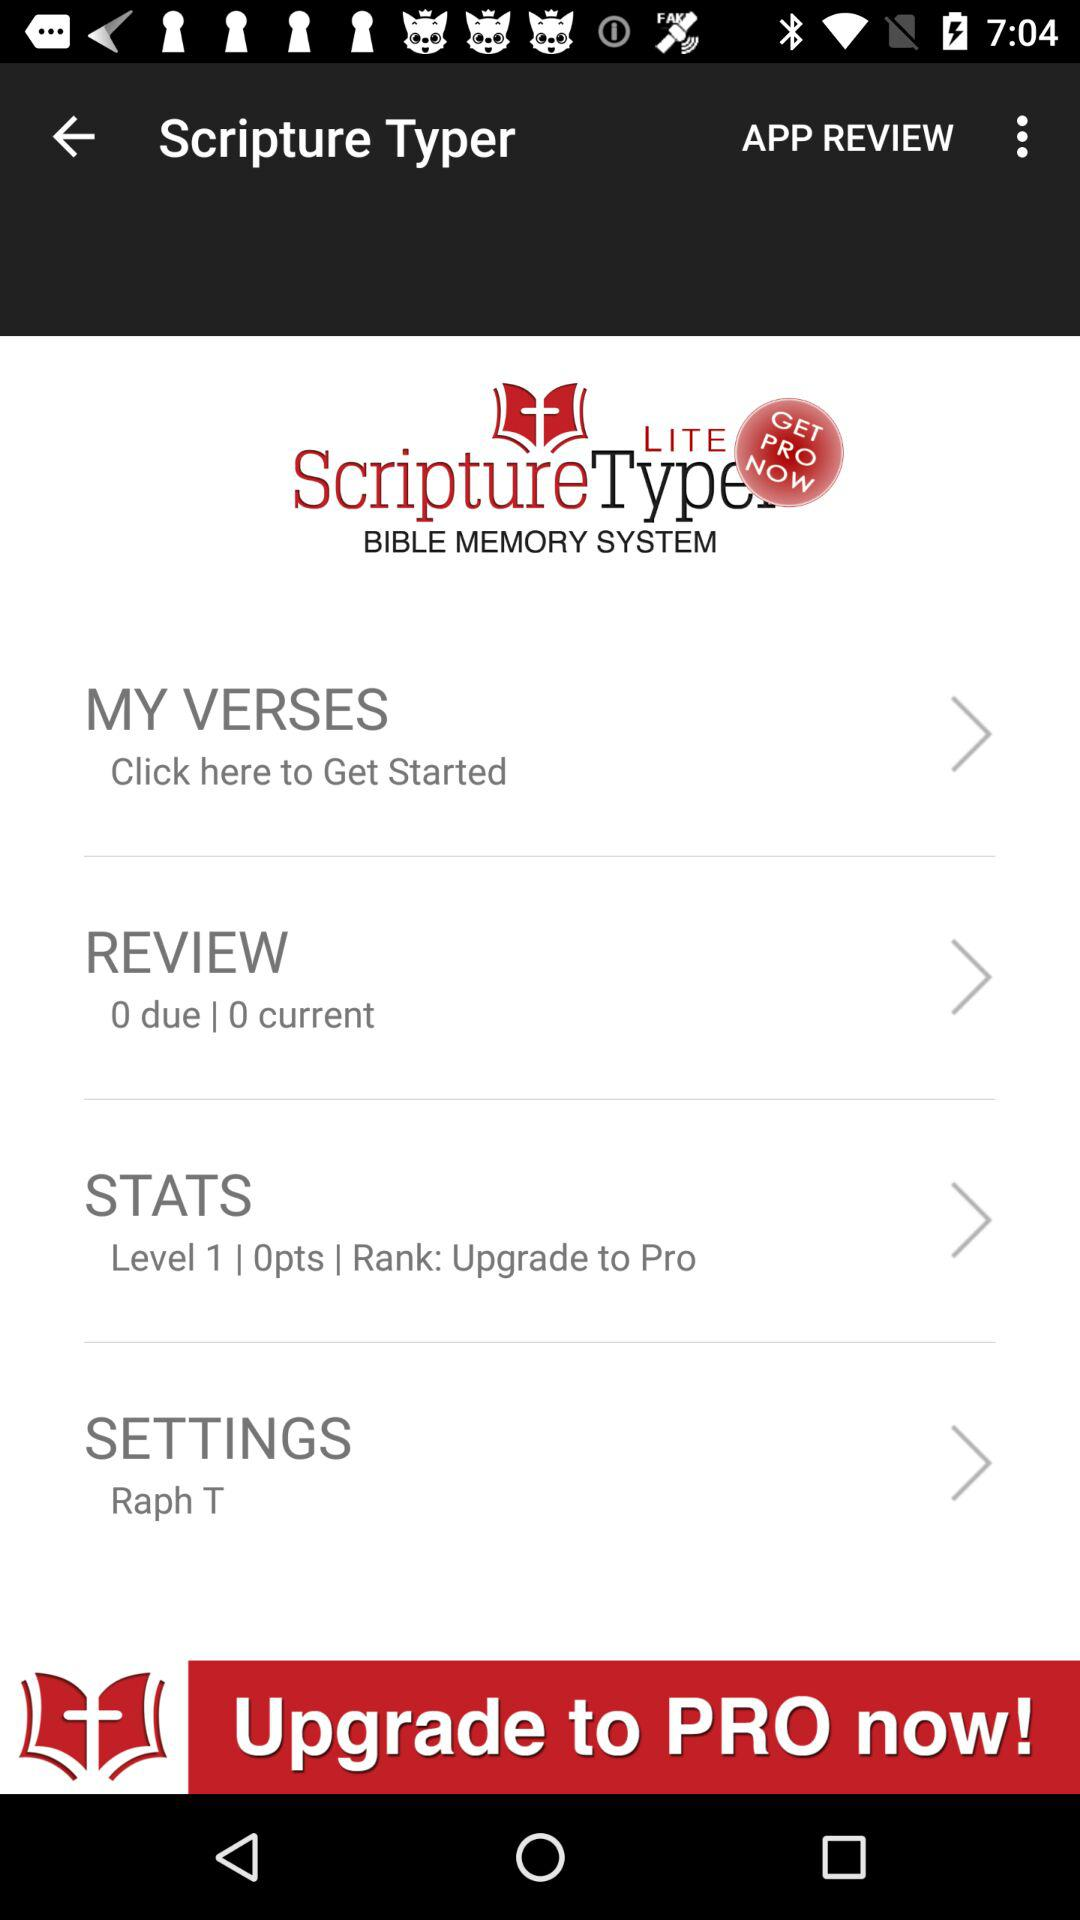What is the level? The level is 1. 